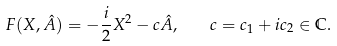Convert formula to latex. <formula><loc_0><loc_0><loc_500><loc_500>F ( X , \hat { A } ) = - \frac { i } { 2 } X ^ { 2 } - c \hat { A } , \quad c = c _ { 1 } + i c _ { 2 } \in \mathbb { C } .</formula> 